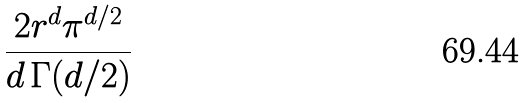Convert formula to latex. <formula><loc_0><loc_0><loc_500><loc_500>\frac { 2 r ^ { d } \pi ^ { d / 2 } } { d \, \Gamma ( d / 2 ) }</formula> 